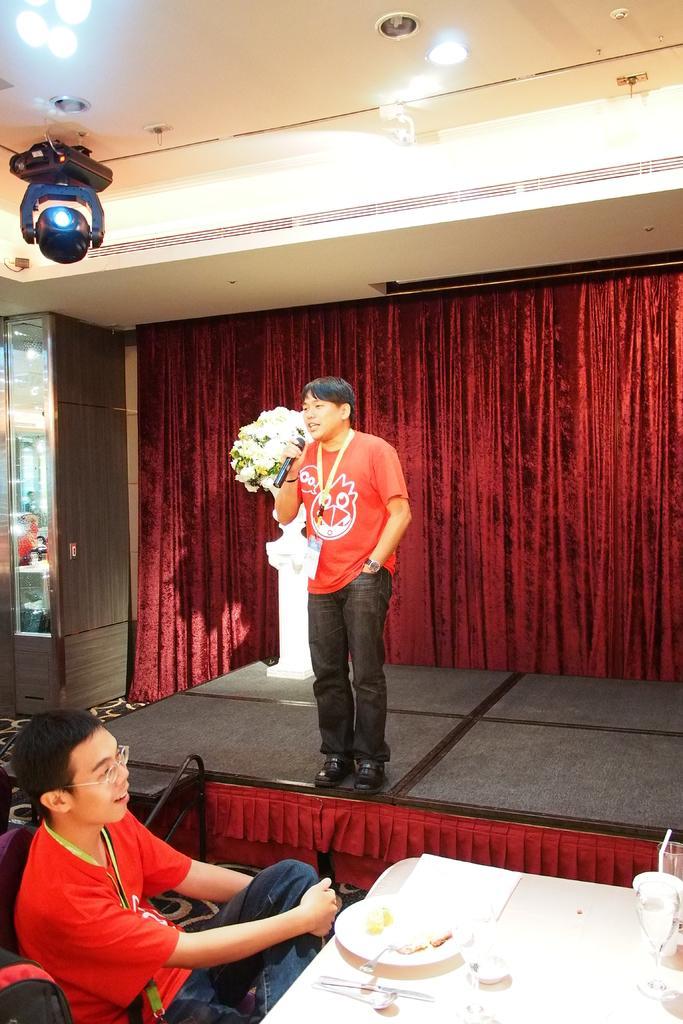Please provide a concise description of this image. A person is sitting wearing a red t shirt. On a white table there is a plate and other objects. A person is standing wearing a red t shirt, id card and holding a microphone in his hand. There are flowers and curtains at the back. There are lights on the top. 